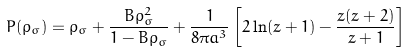<formula> <loc_0><loc_0><loc_500><loc_500>P ( \rho _ { \sigma } ) = \rho _ { \sigma } + \frac { B \rho _ { \sigma } ^ { 2 } } { 1 - B \rho _ { \sigma } } + \frac { 1 } { 8 \pi a ^ { 3 } } \left [ 2 \ln ( z + 1 ) - \frac { z ( z + 2 ) } { z + 1 } \right ]</formula> 